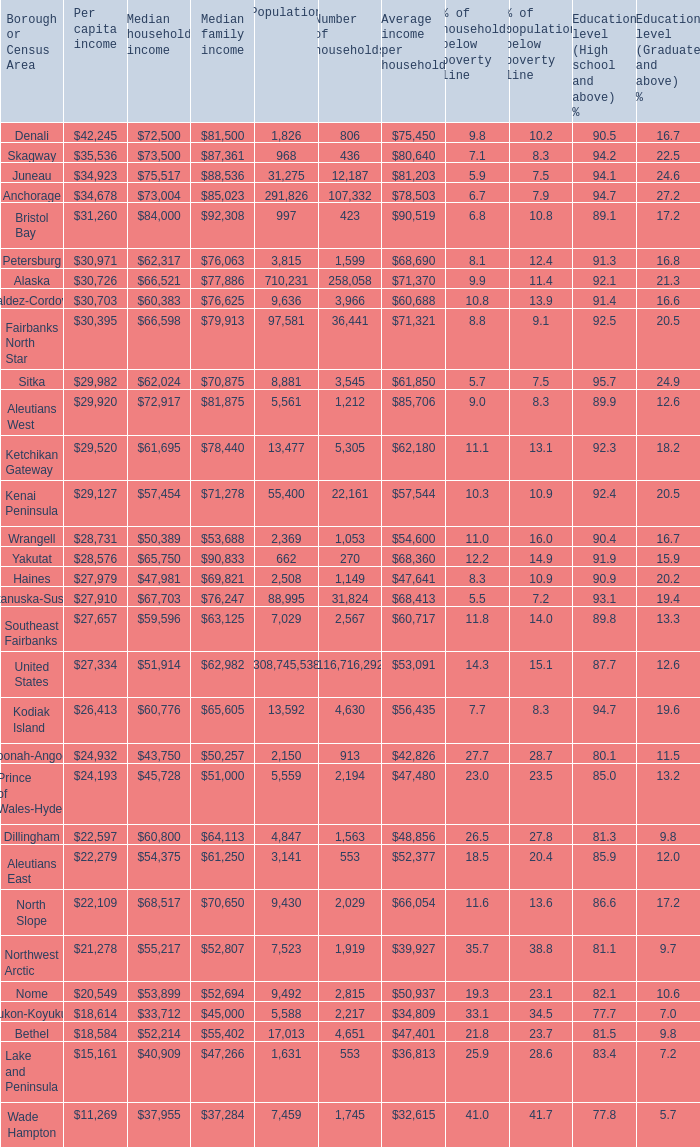Give me the full table as a dictionary. {'header': ['Borough or Census Area', 'Per capita income', 'Median household income', 'Median family income', 'Population', 'Number of households', 'Average income per household', '% of households below poverty line', '% of population below poverty line', 'Education level (High school and above) %', 'Education level (Graduate and above) %'], 'rows': [['Denali', '$42,245', '$72,500', '$81,500', '1,826', '806', '$75,450', '9.8', '10.2', '90.5', '16.7'], ['Skagway', '$35,536', '$73,500', '$87,361', '968', '436', '$80,640', '7.1', '8.3', '94.2', '22.5'], ['Juneau', '$34,923', '$75,517', '$88,536', '31,275', '12,187', '$81,203', '5.9', '7.5', '94.1', '24.6'], ['Anchorage', '$34,678', '$73,004', '$85,023', '291,826', '107,332', '$78,503', '6.7', '7.9', '94.7', '27.2'], ['Bristol Bay', '$31,260', '$84,000', '$92,308', '997', '423', '$90,519', '6.8', '10.8', '89.1', '17.2'], ['Petersburg', '$30,971', '$62,317', '$76,063', '3,815', '1,599', '$68,690', '8.1', '12.4', '91.3', '16.8'], ['Alaska', '$30,726', '$66,521', '$77,886', '710,231', '258,058', '$71,370', '9.9', '11.4', '92.1', '21.3'], ['Valdez-Cordova', '$30,703', '$60,383', '$76,625', '9,636', '3,966', '$60,688', '10.8', '13.9', '91.4', '16.6'], ['Fairbanks North Star', '$30,395', '$66,598', '$79,913', '97,581', '36,441', '$71,321', '8.8', '9.1', '92.5', '20.5'], ['Sitka', '$29,982', '$62,024', '$70,875', '8,881', '3,545', '$61,850', '5.7', '7.5', '95.7', '24.9'], ['Aleutians West', '$29,920', '$72,917', '$81,875', '5,561', '1,212', '$85,706', '9.0', '8.3', '89.9', '12.6'], ['Ketchikan Gateway', '$29,520', '$61,695', '$78,440', '13,477', '5,305', '$62,180', '11.1', '13.1', '92.3', '18.2'], ['Kenai Peninsula', '$29,127', '$57,454', '$71,278', '55,400', '22,161', '$57,544', '10.3', '10.9', '92.4', '20.5'], ['Wrangell', '$28,731', '$50,389', '$53,688', '2,369', '1,053', '$54,600', '11.0', '16.0', '90.4', '16.7'], ['Yakutat', '$28,576', '$65,750', '$90,833', '662', '270', '$68,360', '12.2', '14.9', '91.9', '15.9'], ['Haines', '$27,979', '$47,981', '$69,821', '2,508', '1,149', '$47,641', '8.3', '10.9', '90.9', '20.2'], ['Matanuska-Susitna', '$27,910', '$67,703', '$76,247', '88,995', '31,824', '$68,413', '5.5', '7.2', '93.1', '19.4'], ['Southeast Fairbanks', '$27,657', '$59,596', '$63,125', '7,029', '2,567', '$60,717', '11.8', '14.0', '89.8', '13.3'], ['United States', '$27,334', '$51,914', '$62,982', '308,745,538', '116,716,292', '$53,091', '14.3', '15.1', '87.7', '12.6'], ['Kodiak Island', '$26,413', '$60,776', '$65,605', '13,592', '4,630', '$56,435', '7.7', '8.3', '94.7', '19.6'], ['Hoonah-Angoon', '$24,932', '$43,750', '$50,257', '2,150', '913', '$42,826', '27.7', '28.7', '80.1', '11.5'], ['Prince of Wales-Hyder', '$24,193', '$45,728', '$51,000', '5,559', '2,194', '$47,480', '23.0', '23.5', '85.0', '13.2'], ['Dillingham', '$22,597', '$60,800', '$64,113', '4,847', '1,563', '$48,856', '26.5', '27.8', '81.3', '9.8'], ['Aleutians East', '$22,279', '$54,375', '$61,250', '3,141', '553', '$52,377', '18.5', '20.4', '85.9', '12.0'], ['North Slope', '$22,109', '$68,517', '$70,650', '9,430', '2,029', '$66,054', '11.6', '13.6', '86.6', '17.2'], ['Northwest Arctic', '$21,278', '$55,217', '$52,807', '7,523', '1,919', '$39,927', '35.7', '38.8', '81.1', '9.7'], ['Nome', '$20,549', '$53,899', '$52,694', '9,492', '2,815', '$50,937', '19.3', '23.1', '82.1', '10.6'], ['Yukon-Koyukuk', '$18,614', '$33,712', '$45,000', '5,588', '2,217', '$34,809', '33.1', '34.5', '77.7', '7.0'], ['Bethel', '$18,584', '$52,214', '$55,402', '17,013', '4,651', '$47,401', '21.8', '23.7', '81.5', '9.8'], ['Lake and Peninsula', '$15,161', '$40,909', '$47,266', '1,631', '553', '$36,813', '25.9', '28.6', '83.4', '7.2'], ['Wade Hampton', '$11,269', '$37,955', '$37,284', '7,459', '1,745', '$32,615', '41.0', '41.7', '77.8', '5.7']]} What is the population of the area with a median family income of $71,278? 1.0. 